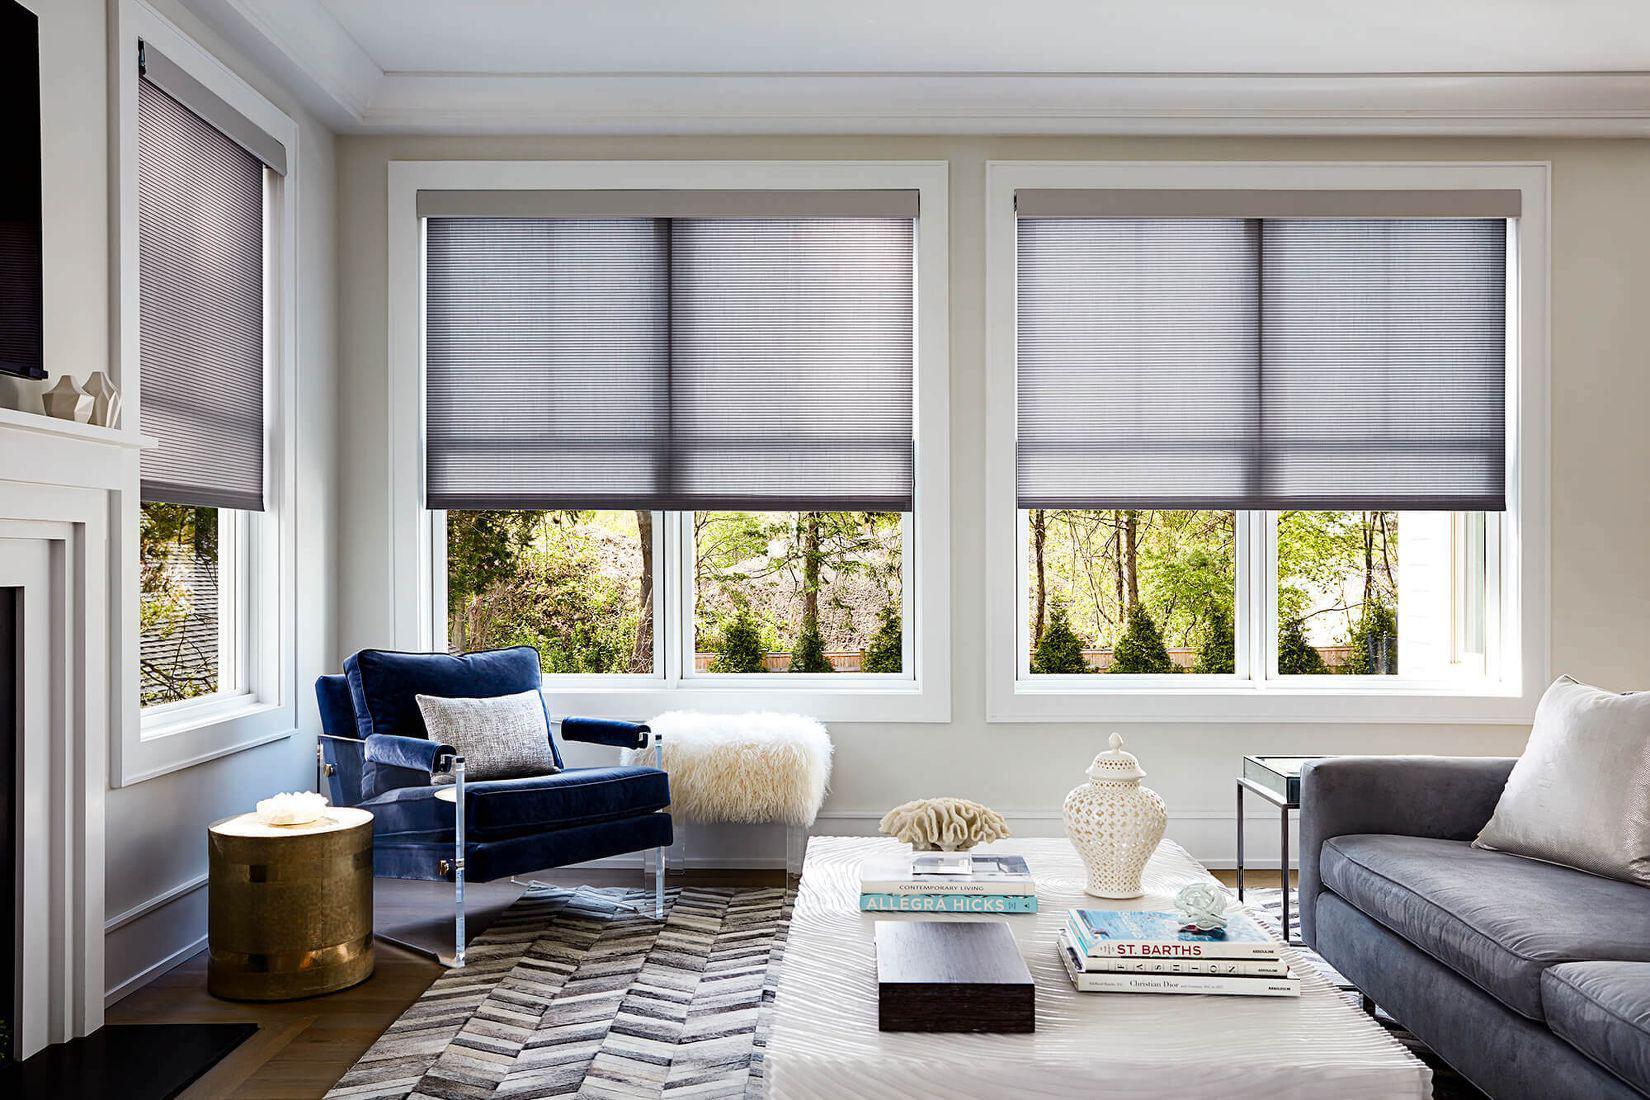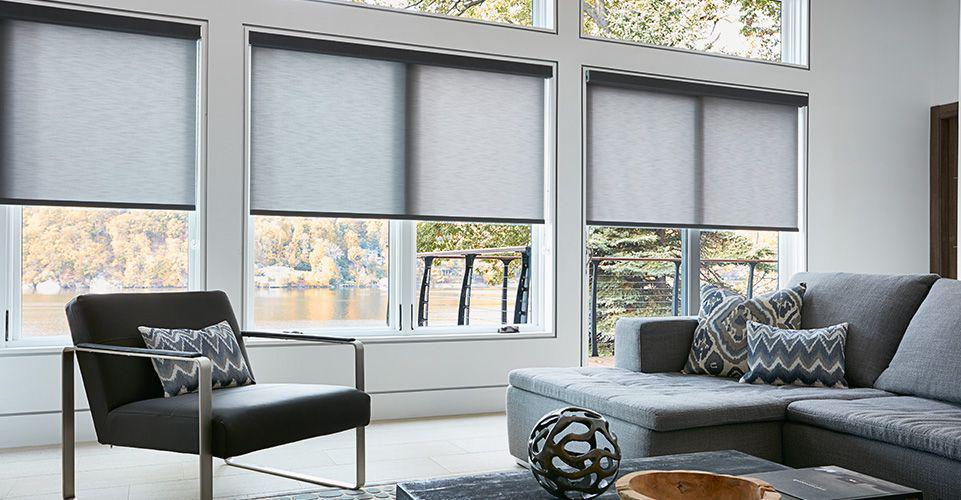The first image is the image on the left, the second image is the image on the right. For the images displayed, is the sentence "There are exactly five shades." factually correct? Answer yes or no. No. The first image is the image on the left, the second image is the image on the right. Examine the images to the left and right. Is the description "There are five blinds." accurate? Answer yes or no. No. 